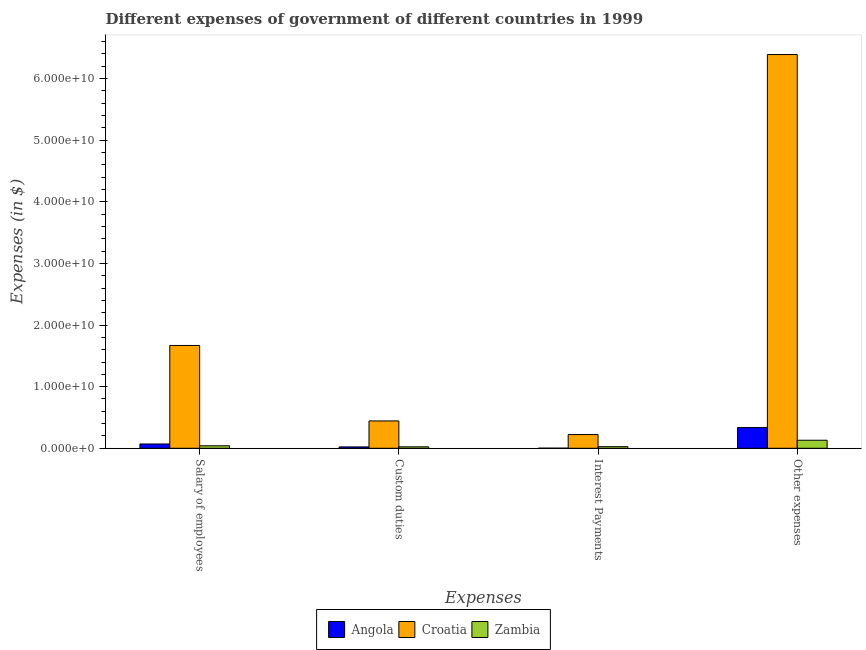Are the number of bars per tick equal to the number of legend labels?
Give a very brief answer. Yes. How many bars are there on the 4th tick from the right?
Provide a short and direct response. 3. What is the label of the 1st group of bars from the left?
Keep it short and to the point. Salary of employees. What is the amount spent on custom duties in Croatia?
Offer a terse response. 4.44e+09. Across all countries, what is the maximum amount spent on custom duties?
Provide a short and direct response. 4.44e+09. Across all countries, what is the minimum amount spent on custom duties?
Your answer should be very brief. 2.21e+08. In which country was the amount spent on interest payments maximum?
Provide a succinct answer. Croatia. In which country was the amount spent on other expenses minimum?
Offer a very short reply. Zambia. What is the total amount spent on interest payments in the graph?
Ensure brevity in your answer.  2.50e+09. What is the difference between the amount spent on custom duties in Angola and that in Zambia?
Provide a succinct answer. -1.48e+07. What is the difference between the amount spent on interest payments in Angola and the amount spent on other expenses in Croatia?
Your answer should be very brief. -6.39e+1. What is the average amount spent on custom duties per country?
Make the answer very short. 1.63e+09. What is the difference between the amount spent on salary of employees and amount spent on other expenses in Croatia?
Give a very brief answer. -4.72e+1. In how many countries, is the amount spent on other expenses greater than 58000000000 $?
Your answer should be very brief. 1. What is the ratio of the amount spent on other expenses in Croatia to that in Angola?
Your answer should be compact. 18.93. What is the difference between the highest and the second highest amount spent on custom duties?
Provide a succinct answer. 4.20e+09. What is the difference between the highest and the lowest amount spent on other expenses?
Your answer should be compact. 6.26e+1. In how many countries, is the amount spent on interest payments greater than the average amount spent on interest payments taken over all countries?
Offer a terse response. 1. Is the sum of the amount spent on other expenses in Zambia and Croatia greater than the maximum amount spent on custom duties across all countries?
Your answer should be compact. Yes. What does the 2nd bar from the left in Salary of employees represents?
Offer a very short reply. Croatia. What does the 1st bar from the right in Interest Payments represents?
Your answer should be very brief. Zambia. How many bars are there?
Make the answer very short. 12. How many countries are there in the graph?
Provide a short and direct response. 3. What is the difference between two consecutive major ticks on the Y-axis?
Provide a succinct answer. 1.00e+1. Are the values on the major ticks of Y-axis written in scientific E-notation?
Ensure brevity in your answer.  Yes. Where does the legend appear in the graph?
Provide a succinct answer. Bottom center. How many legend labels are there?
Provide a succinct answer. 3. How are the legend labels stacked?
Your answer should be very brief. Horizontal. What is the title of the graph?
Your answer should be very brief. Different expenses of government of different countries in 1999. What is the label or title of the X-axis?
Ensure brevity in your answer.  Expenses. What is the label or title of the Y-axis?
Your answer should be very brief. Expenses (in $). What is the Expenses (in $) of Angola in Salary of employees?
Give a very brief answer. 6.98e+08. What is the Expenses (in $) in Croatia in Salary of employees?
Provide a succinct answer. 1.67e+1. What is the Expenses (in $) in Zambia in Salary of employees?
Keep it short and to the point. 4.06e+08. What is the Expenses (in $) of Angola in Custom duties?
Provide a succinct answer. 2.21e+08. What is the Expenses (in $) of Croatia in Custom duties?
Offer a terse response. 4.44e+09. What is the Expenses (in $) of Zambia in Custom duties?
Offer a very short reply. 2.36e+08. What is the Expenses (in $) of Angola in Interest Payments?
Make the answer very short. 1.74e+07. What is the Expenses (in $) in Croatia in Interest Payments?
Your answer should be very brief. 2.23e+09. What is the Expenses (in $) of Zambia in Interest Payments?
Ensure brevity in your answer.  2.59e+08. What is the Expenses (in $) of Angola in Other expenses?
Offer a very short reply. 3.37e+09. What is the Expenses (in $) in Croatia in Other expenses?
Keep it short and to the point. 6.39e+1. What is the Expenses (in $) of Zambia in Other expenses?
Your response must be concise. 1.30e+09. Across all Expenses, what is the maximum Expenses (in $) in Angola?
Provide a succinct answer. 3.37e+09. Across all Expenses, what is the maximum Expenses (in $) of Croatia?
Provide a short and direct response. 6.39e+1. Across all Expenses, what is the maximum Expenses (in $) in Zambia?
Your response must be concise. 1.30e+09. Across all Expenses, what is the minimum Expenses (in $) of Angola?
Your answer should be very brief. 1.74e+07. Across all Expenses, what is the minimum Expenses (in $) in Croatia?
Offer a terse response. 2.23e+09. Across all Expenses, what is the minimum Expenses (in $) of Zambia?
Give a very brief answer. 2.36e+08. What is the total Expenses (in $) of Angola in the graph?
Keep it short and to the point. 4.31e+09. What is the total Expenses (in $) of Croatia in the graph?
Make the answer very short. 8.72e+1. What is the total Expenses (in $) of Zambia in the graph?
Your answer should be compact. 2.20e+09. What is the difference between the Expenses (in $) in Angola in Salary of employees and that in Custom duties?
Ensure brevity in your answer.  4.77e+08. What is the difference between the Expenses (in $) of Croatia in Salary of employees and that in Custom duties?
Give a very brief answer. 1.22e+1. What is the difference between the Expenses (in $) in Zambia in Salary of employees and that in Custom duties?
Keep it short and to the point. 1.70e+08. What is the difference between the Expenses (in $) of Angola in Salary of employees and that in Interest Payments?
Your answer should be very brief. 6.80e+08. What is the difference between the Expenses (in $) of Croatia in Salary of employees and that in Interest Payments?
Offer a terse response. 1.45e+1. What is the difference between the Expenses (in $) in Zambia in Salary of employees and that in Interest Payments?
Give a very brief answer. 1.46e+08. What is the difference between the Expenses (in $) in Angola in Salary of employees and that in Other expenses?
Give a very brief answer. -2.68e+09. What is the difference between the Expenses (in $) of Croatia in Salary of employees and that in Other expenses?
Make the answer very short. -4.72e+1. What is the difference between the Expenses (in $) of Zambia in Salary of employees and that in Other expenses?
Your answer should be compact. -8.98e+08. What is the difference between the Expenses (in $) of Angola in Custom duties and that in Interest Payments?
Give a very brief answer. 2.04e+08. What is the difference between the Expenses (in $) in Croatia in Custom duties and that in Interest Payments?
Offer a very short reply. 2.21e+09. What is the difference between the Expenses (in $) of Zambia in Custom duties and that in Interest Payments?
Your answer should be very brief. -2.33e+07. What is the difference between the Expenses (in $) of Angola in Custom duties and that in Other expenses?
Ensure brevity in your answer.  -3.15e+09. What is the difference between the Expenses (in $) in Croatia in Custom duties and that in Other expenses?
Your answer should be compact. -5.95e+1. What is the difference between the Expenses (in $) in Zambia in Custom duties and that in Other expenses?
Your response must be concise. -1.07e+09. What is the difference between the Expenses (in $) in Angola in Interest Payments and that in Other expenses?
Provide a short and direct response. -3.36e+09. What is the difference between the Expenses (in $) in Croatia in Interest Payments and that in Other expenses?
Keep it short and to the point. -6.17e+1. What is the difference between the Expenses (in $) of Zambia in Interest Payments and that in Other expenses?
Offer a terse response. -1.04e+09. What is the difference between the Expenses (in $) in Angola in Salary of employees and the Expenses (in $) in Croatia in Custom duties?
Give a very brief answer. -3.74e+09. What is the difference between the Expenses (in $) in Angola in Salary of employees and the Expenses (in $) in Zambia in Custom duties?
Ensure brevity in your answer.  4.62e+08. What is the difference between the Expenses (in $) in Croatia in Salary of employees and the Expenses (in $) in Zambia in Custom duties?
Ensure brevity in your answer.  1.65e+1. What is the difference between the Expenses (in $) in Angola in Salary of employees and the Expenses (in $) in Croatia in Interest Payments?
Offer a very short reply. -1.53e+09. What is the difference between the Expenses (in $) in Angola in Salary of employees and the Expenses (in $) in Zambia in Interest Payments?
Your answer should be compact. 4.39e+08. What is the difference between the Expenses (in $) in Croatia in Salary of employees and the Expenses (in $) in Zambia in Interest Payments?
Provide a succinct answer. 1.64e+1. What is the difference between the Expenses (in $) in Angola in Salary of employees and the Expenses (in $) in Croatia in Other expenses?
Your response must be concise. -6.32e+1. What is the difference between the Expenses (in $) in Angola in Salary of employees and the Expenses (in $) in Zambia in Other expenses?
Offer a terse response. -6.06e+08. What is the difference between the Expenses (in $) in Croatia in Salary of employees and the Expenses (in $) in Zambia in Other expenses?
Your answer should be very brief. 1.54e+1. What is the difference between the Expenses (in $) in Angola in Custom duties and the Expenses (in $) in Croatia in Interest Payments?
Offer a terse response. -2.01e+09. What is the difference between the Expenses (in $) of Angola in Custom duties and the Expenses (in $) of Zambia in Interest Payments?
Make the answer very short. -3.81e+07. What is the difference between the Expenses (in $) in Croatia in Custom duties and the Expenses (in $) in Zambia in Interest Payments?
Ensure brevity in your answer.  4.18e+09. What is the difference between the Expenses (in $) of Angola in Custom duties and the Expenses (in $) of Croatia in Other expenses?
Provide a succinct answer. -6.37e+1. What is the difference between the Expenses (in $) in Angola in Custom duties and the Expenses (in $) in Zambia in Other expenses?
Offer a very short reply. -1.08e+09. What is the difference between the Expenses (in $) in Croatia in Custom duties and the Expenses (in $) in Zambia in Other expenses?
Your answer should be compact. 3.13e+09. What is the difference between the Expenses (in $) of Angola in Interest Payments and the Expenses (in $) of Croatia in Other expenses?
Offer a very short reply. -6.39e+1. What is the difference between the Expenses (in $) in Angola in Interest Payments and the Expenses (in $) in Zambia in Other expenses?
Keep it short and to the point. -1.29e+09. What is the difference between the Expenses (in $) of Croatia in Interest Payments and the Expenses (in $) of Zambia in Other expenses?
Give a very brief answer. 9.24e+08. What is the average Expenses (in $) of Angola per Expenses?
Offer a terse response. 1.08e+09. What is the average Expenses (in $) in Croatia per Expenses?
Offer a terse response. 2.18e+1. What is the average Expenses (in $) in Zambia per Expenses?
Your answer should be compact. 5.51e+08. What is the difference between the Expenses (in $) of Angola and Expenses (in $) of Croatia in Salary of employees?
Make the answer very short. -1.60e+1. What is the difference between the Expenses (in $) in Angola and Expenses (in $) in Zambia in Salary of employees?
Give a very brief answer. 2.92e+08. What is the difference between the Expenses (in $) of Croatia and Expenses (in $) of Zambia in Salary of employees?
Your response must be concise. 1.63e+1. What is the difference between the Expenses (in $) in Angola and Expenses (in $) in Croatia in Custom duties?
Offer a terse response. -4.22e+09. What is the difference between the Expenses (in $) of Angola and Expenses (in $) of Zambia in Custom duties?
Give a very brief answer. -1.48e+07. What is the difference between the Expenses (in $) of Croatia and Expenses (in $) of Zambia in Custom duties?
Ensure brevity in your answer.  4.20e+09. What is the difference between the Expenses (in $) in Angola and Expenses (in $) in Croatia in Interest Payments?
Offer a terse response. -2.21e+09. What is the difference between the Expenses (in $) of Angola and Expenses (in $) of Zambia in Interest Payments?
Provide a succinct answer. -2.42e+08. What is the difference between the Expenses (in $) in Croatia and Expenses (in $) in Zambia in Interest Payments?
Keep it short and to the point. 1.97e+09. What is the difference between the Expenses (in $) of Angola and Expenses (in $) of Croatia in Other expenses?
Provide a short and direct response. -6.05e+1. What is the difference between the Expenses (in $) in Angola and Expenses (in $) in Zambia in Other expenses?
Your answer should be very brief. 2.07e+09. What is the difference between the Expenses (in $) in Croatia and Expenses (in $) in Zambia in Other expenses?
Your answer should be compact. 6.26e+1. What is the ratio of the Expenses (in $) of Angola in Salary of employees to that in Custom duties?
Give a very brief answer. 3.15. What is the ratio of the Expenses (in $) in Croatia in Salary of employees to that in Custom duties?
Ensure brevity in your answer.  3.76. What is the ratio of the Expenses (in $) of Zambia in Salary of employees to that in Custom duties?
Your answer should be compact. 1.72. What is the ratio of the Expenses (in $) of Angola in Salary of employees to that in Interest Payments?
Offer a terse response. 40.09. What is the ratio of the Expenses (in $) in Croatia in Salary of employees to that in Interest Payments?
Your response must be concise. 7.49. What is the ratio of the Expenses (in $) in Zambia in Salary of employees to that in Interest Payments?
Provide a succinct answer. 1.56. What is the ratio of the Expenses (in $) of Angola in Salary of employees to that in Other expenses?
Offer a very short reply. 0.21. What is the ratio of the Expenses (in $) of Croatia in Salary of employees to that in Other expenses?
Your response must be concise. 0.26. What is the ratio of the Expenses (in $) of Zambia in Salary of employees to that in Other expenses?
Offer a terse response. 0.31. What is the ratio of the Expenses (in $) in Angola in Custom duties to that in Interest Payments?
Give a very brief answer. 12.71. What is the ratio of the Expenses (in $) of Croatia in Custom duties to that in Interest Payments?
Your answer should be compact. 1.99. What is the ratio of the Expenses (in $) of Zambia in Custom duties to that in Interest Payments?
Offer a very short reply. 0.91. What is the ratio of the Expenses (in $) in Angola in Custom duties to that in Other expenses?
Your answer should be very brief. 0.07. What is the ratio of the Expenses (in $) of Croatia in Custom duties to that in Other expenses?
Offer a very short reply. 0.07. What is the ratio of the Expenses (in $) of Zambia in Custom duties to that in Other expenses?
Offer a very short reply. 0.18. What is the ratio of the Expenses (in $) of Angola in Interest Payments to that in Other expenses?
Provide a succinct answer. 0.01. What is the ratio of the Expenses (in $) of Croatia in Interest Payments to that in Other expenses?
Your answer should be very brief. 0.03. What is the ratio of the Expenses (in $) in Zambia in Interest Payments to that in Other expenses?
Ensure brevity in your answer.  0.2. What is the difference between the highest and the second highest Expenses (in $) of Angola?
Provide a short and direct response. 2.68e+09. What is the difference between the highest and the second highest Expenses (in $) of Croatia?
Ensure brevity in your answer.  4.72e+1. What is the difference between the highest and the second highest Expenses (in $) in Zambia?
Offer a terse response. 8.98e+08. What is the difference between the highest and the lowest Expenses (in $) in Angola?
Keep it short and to the point. 3.36e+09. What is the difference between the highest and the lowest Expenses (in $) in Croatia?
Keep it short and to the point. 6.17e+1. What is the difference between the highest and the lowest Expenses (in $) in Zambia?
Your answer should be compact. 1.07e+09. 